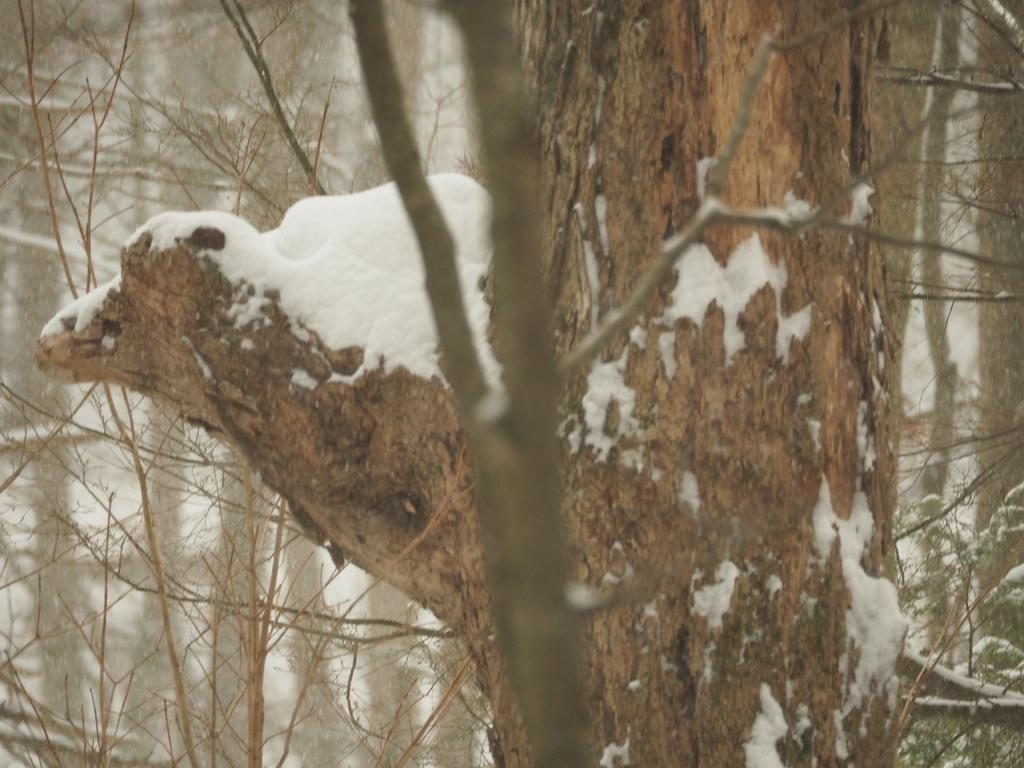What is the main subject in the foreground of the image? There is a tree trunk in the foreground of the image. What is covering the tree trunk? There is snow on the tree trunk. What can be seen on the stems in the image? There are stems without leaves in the image. Where is the tree with snow located in the image? There is a tree with snow on the right side of the image. What type of pen is being used to draw on the snow-covered tree trunk? There is no pen or drawing present in the image; it only features trees and stems without leaves. 